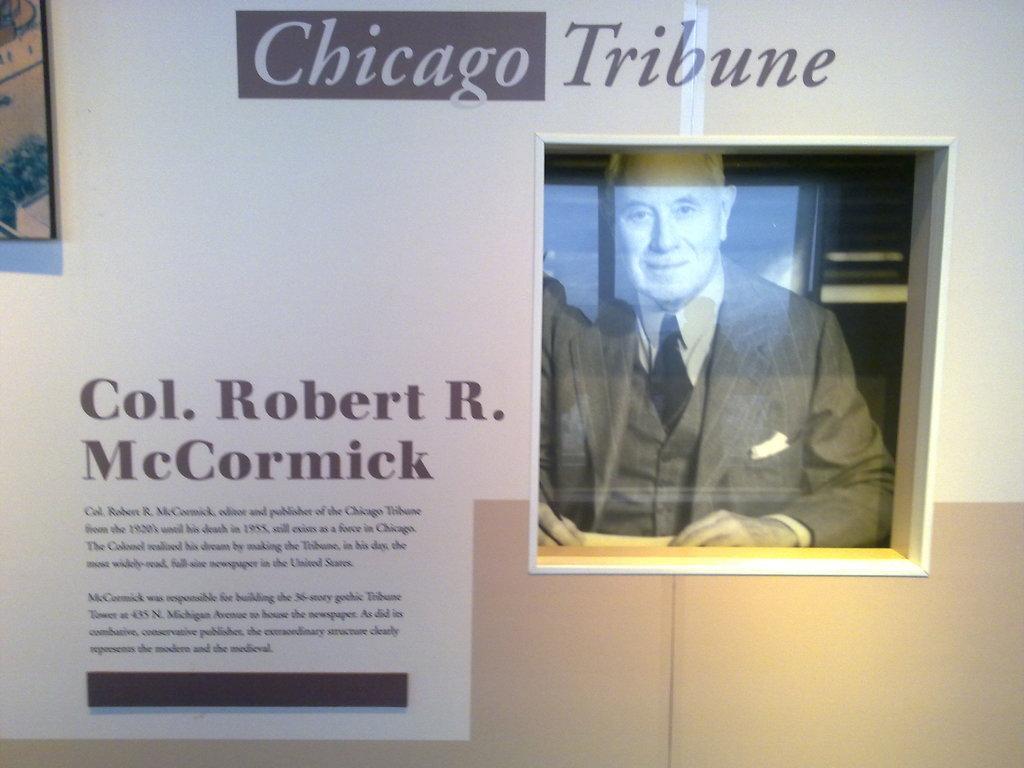In one or two sentences, can you explain what this image depicts? In this image in the center there is one photo frame, in that photo frame there is one person and there are some posters on the wall and on the posters there is some text. 